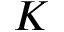<formula> <loc_0><loc_0><loc_500><loc_500>K</formula> 